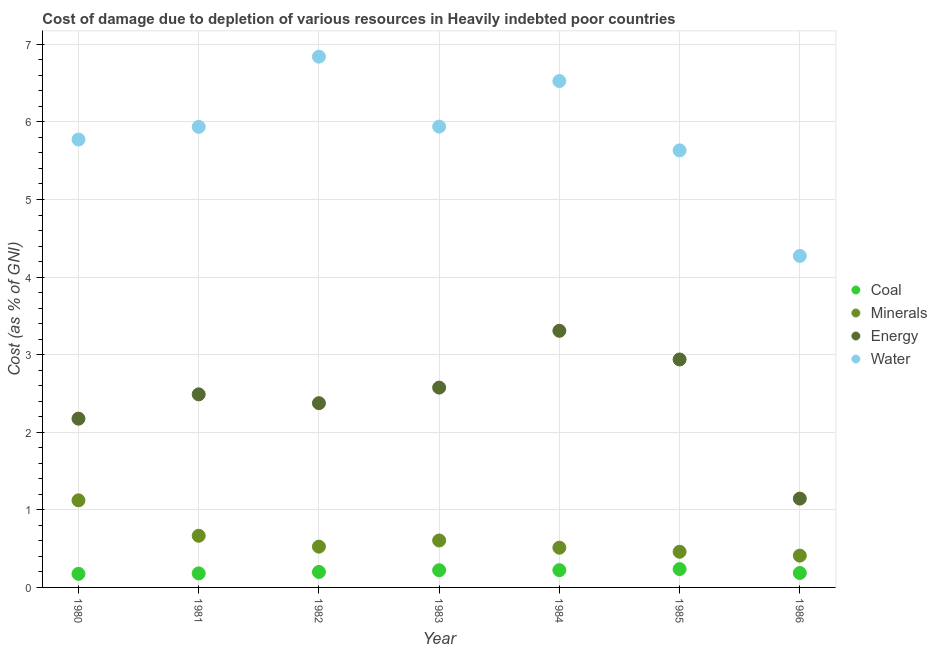How many different coloured dotlines are there?
Provide a succinct answer. 4. Is the number of dotlines equal to the number of legend labels?
Make the answer very short. Yes. What is the cost of damage due to depletion of coal in 1981?
Offer a very short reply. 0.18. Across all years, what is the maximum cost of damage due to depletion of water?
Your answer should be compact. 6.84. Across all years, what is the minimum cost of damage due to depletion of energy?
Offer a very short reply. 1.14. In which year was the cost of damage due to depletion of water maximum?
Ensure brevity in your answer.  1982. What is the total cost of damage due to depletion of energy in the graph?
Give a very brief answer. 17. What is the difference between the cost of damage due to depletion of water in 1980 and that in 1985?
Offer a terse response. 0.14. What is the difference between the cost of damage due to depletion of coal in 1981 and the cost of damage due to depletion of minerals in 1986?
Offer a very short reply. -0.23. What is the average cost of damage due to depletion of minerals per year?
Provide a short and direct response. 0.61. In the year 1981, what is the difference between the cost of damage due to depletion of water and cost of damage due to depletion of minerals?
Your answer should be very brief. 5.27. In how many years, is the cost of damage due to depletion of energy greater than 1.8 %?
Give a very brief answer. 6. What is the ratio of the cost of damage due to depletion of water in 1980 to that in 1986?
Keep it short and to the point. 1.35. What is the difference between the highest and the second highest cost of damage due to depletion of coal?
Offer a terse response. 0.01. What is the difference between the highest and the lowest cost of damage due to depletion of minerals?
Make the answer very short. 0.71. Is it the case that in every year, the sum of the cost of damage due to depletion of coal and cost of damage due to depletion of minerals is greater than the cost of damage due to depletion of energy?
Your response must be concise. No. Does the cost of damage due to depletion of energy monotonically increase over the years?
Your answer should be very brief. No. Is the cost of damage due to depletion of minerals strictly greater than the cost of damage due to depletion of water over the years?
Your answer should be compact. No. Is the cost of damage due to depletion of water strictly less than the cost of damage due to depletion of coal over the years?
Keep it short and to the point. No. How many dotlines are there?
Provide a short and direct response. 4. How many years are there in the graph?
Provide a succinct answer. 7. Does the graph contain grids?
Offer a terse response. Yes. Where does the legend appear in the graph?
Provide a short and direct response. Center right. How many legend labels are there?
Provide a succinct answer. 4. What is the title of the graph?
Give a very brief answer. Cost of damage due to depletion of various resources in Heavily indebted poor countries . Does "Secondary vocational education" appear as one of the legend labels in the graph?
Offer a terse response. No. What is the label or title of the X-axis?
Your answer should be very brief. Year. What is the label or title of the Y-axis?
Provide a succinct answer. Cost (as % of GNI). What is the Cost (as % of GNI) in Coal in 1980?
Offer a very short reply. 0.18. What is the Cost (as % of GNI) in Minerals in 1980?
Offer a terse response. 1.12. What is the Cost (as % of GNI) of Energy in 1980?
Offer a terse response. 2.18. What is the Cost (as % of GNI) of Water in 1980?
Make the answer very short. 5.77. What is the Cost (as % of GNI) of Coal in 1981?
Provide a short and direct response. 0.18. What is the Cost (as % of GNI) of Minerals in 1981?
Ensure brevity in your answer.  0.67. What is the Cost (as % of GNI) in Energy in 1981?
Provide a short and direct response. 2.49. What is the Cost (as % of GNI) in Water in 1981?
Offer a terse response. 5.94. What is the Cost (as % of GNI) in Coal in 1982?
Ensure brevity in your answer.  0.2. What is the Cost (as % of GNI) in Minerals in 1982?
Your answer should be compact. 0.53. What is the Cost (as % of GNI) in Energy in 1982?
Your answer should be compact. 2.37. What is the Cost (as % of GNI) in Water in 1982?
Provide a succinct answer. 6.84. What is the Cost (as % of GNI) of Coal in 1983?
Provide a short and direct response. 0.22. What is the Cost (as % of GNI) of Minerals in 1983?
Your response must be concise. 0.61. What is the Cost (as % of GNI) in Energy in 1983?
Your response must be concise. 2.58. What is the Cost (as % of GNI) in Water in 1983?
Give a very brief answer. 5.94. What is the Cost (as % of GNI) in Coal in 1984?
Your answer should be compact. 0.22. What is the Cost (as % of GNI) of Minerals in 1984?
Your answer should be compact. 0.51. What is the Cost (as % of GNI) in Energy in 1984?
Ensure brevity in your answer.  3.31. What is the Cost (as % of GNI) in Water in 1984?
Ensure brevity in your answer.  6.53. What is the Cost (as % of GNI) of Coal in 1985?
Offer a very short reply. 0.24. What is the Cost (as % of GNI) in Minerals in 1985?
Your answer should be compact. 0.46. What is the Cost (as % of GNI) of Energy in 1985?
Your answer should be very brief. 2.94. What is the Cost (as % of GNI) in Water in 1985?
Give a very brief answer. 5.63. What is the Cost (as % of GNI) in Coal in 1986?
Ensure brevity in your answer.  0.19. What is the Cost (as % of GNI) of Minerals in 1986?
Make the answer very short. 0.41. What is the Cost (as % of GNI) of Energy in 1986?
Give a very brief answer. 1.14. What is the Cost (as % of GNI) of Water in 1986?
Keep it short and to the point. 4.27. Across all years, what is the maximum Cost (as % of GNI) of Coal?
Ensure brevity in your answer.  0.24. Across all years, what is the maximum Cost (as % of GNI) in Minerals?
Provide a succinct answer. 1.12. Across all years, what is the maximum Cost (as % of GNI) of Energy?
Provide a succinct answer. 3.31. Across all years, what is the maximum Cost (as % of GNI) in Water?
Your answer should be compact. 6.84. Across all years, what is the minimum Cost (as % of GNI) in Coal?
Give a very brief answer. 0.18. Across all years, what is the minimum Cost (as % of GNI) of Minerals?
Make the answer very short. 0.41. Across all years, what is the minimum Cost (as % of GNI) in Energy?
Provide a short and direct response. 1.14. Across all years, what is the minimum Cost (as % of GNI) of Water?
Provide a short and direct response. 4.27. What is the total Cost (as % of GNI) in Coal in the graph?
Offer a terse response. 1.42. What is the total Cost (as % of GNI) of Minerals in the graph?
Your answer should be very brief. 4.3. What is the total Cost (as % of GNI) of Energy in the graph?
Provide a short and direct response. 17. What is the total Cost (as % of GNI) of Water in the graph?
Provide a succinct answer. 40.92. What is the difference between the Cost (as % of GNI) in Coal in 1980 and that in 1981?
Offer a terse response. -0.01. What is the difference between the Cost (as % of GNI) in Minerals in 1980 and that in 1981?
Your response must be concise. 0.46. What is the difference between the Cost (as % of GNI) in Energy in 1980 and that in 1981?
Offer a very short reply. -0.31. What is the difference between the Cost (as % of GNI) in Water in 1980 and that in 1981?
Your answer should be compact. -0.16. What is the difference between the Cost (as % of GNI) of Coal in 1980 and that in 1982?
Your response must be concise. -0.02. What is the difference between the Cost (as % of GNI) of Minerals in 1980 and that in 1982?
Keep it short and to the point. 0.6. What is the difference between the Cost (as % of GNI) of Energy in 1980 and that in 1982?
Provide a succinct answer. -0.2. What is the difference between the Cost (as % of GNI) in Water in 1980 and that in 1982?
Make the answer very short. -1.07. What is the difference between the Cost (as % of GNI) in Coal in 1980 and that in 1983?
Ensure brevity in your answer.  -0.05. What is the difference between the Cost (as % of GNI) in Minerals in 1980 and that in 1983?
Your answer should be very brief. 0.52. What is the difference between the Cost (as % of GNI) of Energy in 1980 and that in 1983?
Your answer should be very brief. -0.4. What is the difference between the Cost (as % of GNI) in Coal in 1980 and that in 1984?
Make the answer very short. -0.05. What is the difference between the Cost (as % of GNI) of Minerals in 1980 and that in 1984?
Keep it short and to the point. 0.61. What is the difference between the Cost (as % of GNI) of Energy in 1980 and that in 1984?
Make the answer very short. -1.13. What is the difference between the Cost (as % of GNI) of Water in 1980 and that in 1984?
Provide a succinct answer. -0.75. What is the difference between the Cost (as % of GNI) of Coal in 1980 and that in 1985?
Make the answer very short. -0.06. What is the difference between the Cost (as % of GNI) in Minerals in 1980 and that in 1985?
Keep it short and to the point. 0.66. What is the difference between the Cost (as % of GNI) in Energy in 1980 and that in 1985?
Provide a short and direct response. -0.76. What is the difference between the Cost (as % of GNI) of Water in 1980 and that in 1985?
Provide a short and direct response. 0.14. What is the difference between the Cost (as % of GNI) in Coal in 1980 and that in 1986?
Your answer should be very brief. -0.01. What is the difference between the Cost (as % of GNI) of Minerals in 1980 and that in 1986?
Provide a succinct answer. 0.71. What is the difference between the Cost (as % of GNI) in Energy in 1980 and that in 1986?
Keep it short and to the point. 1.03. What is the difference between the Cost (as % of GNI) of Water in 1980 and that in 1986?
Keep it short and to the point. 1.5. What is the difference between the Cost (as % of GNI) of Coal in 1981 and that in 1982?
Keep it short and to the point. -0.02. What is the difference between the Cost (as % of GNI) in Minerals in 1981 and that in 1982?
Provide a succinct answer. 0.14. What is the difference between the Cost (as % of GNI) of Energy in 1981 and that in 1982?
Keep it short and to the point. 0.11. What is the difference between the Cost (as % of GNI) of Water in 1981 and that in 1982?
Your answer should be very brief. -0.9. What is the difference between the Cost (as % of GNI) in Coal in 1981 and that in 1983?
Ensure brevity in your answer.  -0.04. What is the difference between the Cost (as % of GNI) in Minerals in 1981 and that in 1983?
Provide a succinct answer. 0.06. What is the difference between the Cost (as % of GNI) in Energy in 1981 and that in 1983?
Give a very brief answer. -0.09. What is the difference between the Cost (as % of GNI) of Water in 1981 and that in 1983?
Your response must be concise. -0. What is the difference between the Cost (as % of GNI) of Coal in 1981 and that in 1984?
Your answer should be very brief. -0.04. What is the difference between the Cost (as % of GNI) of Minerals in 1981 and that in 1984?
Ensure brevity in your answer.  0.15. What is the difference between the Cost (as % of GNI) of Energy in 1981 and that in 1984?
Ensure brevity in your answer.  -0.82. What is the difference between the Cost (as % of GNI) of Water in 1981 and that in 1984?
Keep it short and to the point. -0.59. What is the difference between the Cost (as % of GNI) of Coal in 1981 and that in 1985?
Make the answer very short. -0.06. What is the difference between the Cost (as % of GNI) in Minerals in 1981 and that in 1985?
Offer a terse response. 0.21. What is the difference between the Cost (as % of GNI) of Energy in 1981 and that in 1985?
Give a very brief answer. -0.45. What is the difference between the Cost (as % of GNI) in Water in 1981 and that in 1985?
Your answer should be very brief. 0.3. What is the difference between the Cost (as % of GNI) in Coal in 1981 and that in 1986?
Your response must be concise. -0.01. What is the difference between the Cost (as % of GNI) of Minerals in 1981 and that in 1986?
Your response must be concise. 0.26. What is the difference between the Cost (as % of GNI) in Energy in 1981 and that in 1986?
Provide a succinct answer. 1.34. What is the difference between the Cost (as % of GNI) of Water in 1981 and that in 1986?
Offer a very short reply. 1.66. What is the difference between the Cost (as % of GNI) in Coal in 1982 and that in 1983?
Offer a very short reply. -0.02. What is the difference between the Cost (as % of GNI) in Minerals in 1982 and that in 1983?
Provide a succinct answer. -0.08. What is the difference between the Cost (as % of GNI) in Energy in 1982 and that in 1983?
Offer a very short reply. -0.2. What is the difference between the Cost (as % of GNI) in Water in 1982 and that in 1983?
Ensure brevity in your answer.  0.9. What is the difference between the Cost (as % of GNI) in Coal in 1982 and that in 1984?
Offer a terse response. -0.02. What is the difference between the Cost (as % of GNI) in Minerals in 1982 and that in 1984?
Provide a short and direct response. 0.01. What is the difference between the Cost (as % of GNI) in Energy in 1982 and that in 1984?
Offer a very short reply. -0.93. What is the difference between the Cost (as % of GNI) in Water in 1982 and that in 1984?
Offer a terse response. 0.31. What is the difference between the Cost (as % of GNI) of Coal in 1982 and that in 1985?
Your response must be concise. -0.04. What is the difference between the Cost (as % of GNI) of Minerals in 1982 and that in 1985?
Offer a terse response. 0.07. What is the difference between the Cost (as % of GNI) in Energy in 1982 and that in 1985?
Ensure brevity in your answer.  -0.56. What is the difference between the Cost (as % of GNI) in Water in 1982 and that in 1985?
Give a very brief answer. 1.21. What is the difference between the Cost (as % of GNI) in Coal in 1982 and that in 1986?
Your answer should be very brief. 0.01. What is the difference between the Cost (as % of GNI) of Minerals in 1982 and that in 1986?
Ensure brevity in your answer.  0.12. What is the difference between the Cost (as % of GNI) of Energy in 1982 and that in 1986?
Offer a terse response. 1.23. What is the difference between the Cost (as % of GNI) of Water in 1982 and that in 1986?
Your answer should be very brief. 2.57. What is the difference between the Cost (as % of GNI) of Coal in 1983 and that in 1984?
Your response must be concise. -0. What is the difference between the Cost (as % of GNI) in Minerals in 1983 and that in 1984?
Your response must be concise. 0.09. What is the difference between the Cost (as % of GNI) of Energy in 1983 and that in 1984?
Make the answer very short. -0.73. What is the difference between the Cost (as % of GNI) of Water in 1983 and that in 1984?
Ensure brevity in your answer.  -0.59. What is the difference between the Cost (as % of GNI) of Coal in 1983 and that in 1985?
Your answer should be very brief. -0.01. What is the difference between the Cost (as % of GNI) of Minerals in 1983 and that in 1985?
Your answer should be compact. 0.15. What is the difference between the Cost (as % of GNI) in Energy in 1983 and that in 1985?
Give a very brief answer. -0.36. What is the difference between the Cost (as % of GNI) of Water in 1983 and that in 1985?
Make the answer very short. 0.31. What is the difference between the Cost (as % of GNI) in Coal in 1983 and that in 1986?
Your answer should be compact. 0.04. What is the difference between the Cost (as % of GNI) of Minerals in 1983 and that in 1986?
Give a very brief answer. 0.2. What is the difference between the Cost (as % of GNI) of Energy in 1983 and that in 1986?
Give a very brief answer. 1.43. What is the difference between the Cost (as % of GNI) in Water in 1983 and that in 1986?
Ensure brevity in your answer.  1.67. What is the difference between the Cost (as % of GNI) in Coal in 1984 and that in 1985?
Keep it short and to the point. -0.01. What is the difference between the Cost (as % of GNI) in Minerals in 1984 and that in 1985?
Your answer should be very brief. 0.05. What is the difference between the Cost (as % of GNI) in Energy in 1984 and that in 1985?
Provide a succinct answer. 0.37. What is the difference between the Cost (as % of GNI) in Water in 1984 and that in 1985?
Provide a short and direct response. 0.89. What is the difference between the Cost (as % of GNI) in Coal in 1984 and that in 1986?
Make the answer very short. 0.04. What is the difference between the Cost (as % of GNI) of Minerals in 1984 and that in 1986?
Give a very brief answer. 0.1. What is the difference between the Cost (as % of GNI) in Energy in 1984 and that in 1986?
Provide a succinct answer. 2.16. What is the difference between the Cost (as % of GNI) in Water in 1984 and that in 1986?
Your response must be concise. 2.25. What is the difference between the Cost (as % of GNI) in Coal in 1985 and that in 1986?
Provide a succinct answer. 0.05. What is the difference between the Cost (as % of GNI) of Minerals in 1985 and that in 1986?
Keep it short and to the point. 0.05. What is the difference between the Cost (as % of GNI) in Energy in 1985 and that in 1986?
Offer a very short reply. 1.79. What is the difference between the Cost (as % of GNI) of Water in 1985 and that in 1986?
Offer a terse response. 1.36. What is the difference between the Cost (as % of GNI) in Coal in 1980 and the Cost (as % of GNI) in Minerals in 1981?
Your response must be concise. -0.49. What is the difference between the Cost (as % of GNI) in Coal in 1980 and the Cost (as % of GNI) in Energy in 1981?
Your answer should be very brief. -2.31. What is the difference between the Cost (as % of GNI) of Coal in 1980 and the Cost (as % of GNI) of Water in 1981?
Your answer should be very brief. -5.76. What is the difference between the Cost (as % of GNI) of Minerals in 1980 and the Cost (as % of GNI) of Energy in 1981?
Your answer should be compact. -1.37. What is the difference between the Cost (as % of GNI) of Minerals in 1980 and the Cost (as % of GNI) of Water in 1981?
Ensure brevity in your answer.  -4.81. What is the difference between the Cost (as % of GNI) in Energy in 1980 and the Cost (as % of GNI) in Water in 1981?
Your answer should be compact. -3.76. What is the difference between the Cost (as % of GNI) in Coal in 1980 and the Cost (as % of GNI) in Minerals in 1982?
Offer a very short reply. -0.35. What is the difference between the Cost (as % of GNI) in Coal in 1980 and the Cost (as % of GNI) in Energy in 1982?
Ensure brevity in your answer.  -2.2. What is the difference between the Cost (as % of GNI) in Coal in 1980 and the Cost (as % of GNI) in Water in 1982?
Your answer should be very brief. -6.67. What is the difference between the Cost (as % of GNI) of Minerals in 1980 and the Cost (as % of GNI) of Energy in 1982?
Give a very brief answer. -1.25. What is the difference between the Cost (as % of GNI) of Minerals in 1980 and the Cost (as % of GNI) of Water in 1982?
Offer a very short reply. -5.72. What is the difference between the Cost (as % of GNI) in Energy in 1980 and the Cost (as % of GNI) in Water in 1982?
Make the answer very short. -4.67. What is the difference between the Cost (as % of GNI) in Coal in 1980 and the Cost (as % of GNI) in Minerals in 1983?
Your answer should be compact. -0.43. What is the difference between the Cost (as % of GNI) in Coal in 1980 and the Cost (as % of GNI) in Energy in 1983?
Offer a terse response. -2.4. What is the difference between the Cost (as % of GNI) of Coal in 1980 and the Cost (as % of GNI) of Water in 1983?
Your response must be concise. -5.76. What is the difference between the Cost (as % of GNI) in Minerals in 1980 and the Cost (as % of GNI) in Energy in 1983?
Your response must be concise. -1.45. What is the difference between the Cost (as % of GNI) in Minerals in 1980 and the Cost (as % of GNI) in Water in 1983?
Offer a very short reply. -4.82. What is the difference between the Cost (as % of GNI) of Energy in 1980 and the Cost (as % of GNI) of Water in 1983?
Keep it short and to the point. -3.76. What is the difference between the Cost (as % of GNI) of Coal in 1980 and the Cost (as % of GNI) of Minerals in 1984?
Offer a very short reply. -0.34. What is the difference between the Cost (as % of GNI) of Coal in 1980 and the Cost (as % of GNI) of Energy in 1984?
Your answer should be compact. -3.13. What is the difference between the Cost (as % of GNI) in Coal in 1980 and the Cost (as % of GNI) in Water in 1984?
Your response must be concise. -6.35. What is the difference between the Cost (as % of GNI) of Minerals in 1980 and the Cost (as % of GNI) of Energy in 1984?
Keep it short and to the point. -2.19. What is the difference between the Cost (as % of GNI) of Minerals in 1980 and the Cost (as % of GNI) of Water in 1984?
Your answer should be compact. -5.4. What is the difference between the Cost (as % of GNI) of Energy in 1980 and the Cost (as % of GNI) of Water in 1984?
Your answer should be very brief. -4.35. What is the difference between the Cost (as % of GNI) in Coal in 1980 and the Cost (as % of GNI) in Minerals in 1985?
Your answer should be compact. -0.28. What is the difference between the Cost (as % of GNI) of Coal in 1980 and the Cost (as % of GNI) of Energy in 1985?
Provide a short and direct response. -2.76. What is the difference between the Cost (as % of GNI) of Coal in 1980 and the Cost (as % of GNI) of Water in 1985?
Your answer should be compact. -5.46. What is the difference between the Cost (as % of GNI) of Minerals in 1980 and the Cost (as % of GNI) of Energy in 1985?
Your answer should be compact. -1.82. What is the difference between the Cost (as % of GNI) of Minerals in 1980 and the Cost (as % of GNI) of Water in 1985?
Make the answer very short. -4.51. What is the difference between the Cost (as % of GNI) of Energy in 1980 and the Cost (as % of GNI) of Water in 1985?
Provide a short and direct response. -3.46. What is the difference between the Cost (as % of GNI) in Coal in 1980 and the Cost (as % of GNI) in Minerals in 1986?
Make the answer very short. -0.23. What is the difference between the Cost (as % of GNI) in Coal in 1980 and the Cost (as % of GNI) in Energy in 1986?
Provide a succinct answer. -0.97. What is the difference between the Cost (as % of GNI) of Coal in 1980 and the Cost (as % of GNI) of Water in 1986?
Offer a very short reply. -4.1. What is the difference between the Cost (as % of GNI) in Minerals in 1980 and the Cost (as % of GNI) in Energy in 1986?
Provide a short and direct response. -0.02. What is the difference between the Cost (as % of GNI) of Minerals in 1980 and the Cost (as % of GNI) of Water in 1986?
Provide a succinct answer. -3.15. What is the difference between the Cost (as % of GNI) in Energy in 1980 and the Cost (as % of GNI) in Water in 1986?
Your answer should be very brief. -2.1. What is the difference between the Cost (as % of GNI) in Coal in 1981 and the Cost (as % of GNI) in Minerals in 1982?
Your answer should be very brief. -0.34. What is the difference between the Cost (as % of GNI) of Coal in 1981 and the Cost (as % of GNI) of Energy in 1982?
Provide a short and direct response. -2.19. What is the difference between the Cost (as % of GNI) of Coal in 1981 and the Cost (as % of GNI) of Water in 1982?
Your answer should be compact. -6.66. What is the difference between the Cost (as % of GNI) of Minerals in 1981 and the Cost (as % of GNI) of Energy in 1982?
Offer a very short reply. -1.71. What is the difference between the Cost (as % of GNI) in Minerals in 1981 and the Cost (as % of GNI) in Water in 1982?
Make the answer very short. -6.17. What is the difference between the Cost (as % of GNI) of Energy in 1981 and the Cost (as % of GNI) of Water in 1982?
Ensure brevity in your answer.  -4.35. What is the difference between the Cost (as % of GNI) of Coal in 1981 and the Cost (as % of GNI) of Minerals in 1983?
Provide a short and direct response. -0.42. What is the difference between the Cost (as % of GNI) in Coal in 1981 and the Cost (as % of GNI) in Energy in 1983?
Keep it short and to the point. -2.39. What is the difference between the Cost (as % of GNI) in Coal in 1981 and the Cost (as % of GNI) in Water in 1983?
Your answer should be compact. -5.76. What is the difference between the Cost (as % of GNI) of Minerals in 1981 and the Cost (as % of GNI) of Energy in 1983?
Offer a terse response. -1.91. What is the difference between the Cost (as % of GNI) in Minerals in 1981 and the Cost (as % of GNI) in Water in 1983?
Ensure brevity in your answer.  -5.27. What is the difference between the Cost (as % of GNI) of Energy in 1981 and the Cost (as % of GNI) of Water in 1983?
Provide a short and direct response. -3.45. What is the difference between the Cost (as % of GNI) of Coal in 1981 and the Cost (as % of GNI) of Minerals in 1984?
Make the answer very short. -0.33. What is the difference between the Cost (as % of GNI) of Coal in 1981 and the Cost (as % of GNI) of Energy in 1984?
Offer a very short reply. -3.13. What is the difference between the Cost (as % of GNI) of Coal in 1981 and the Cost (as % of GNI) of Water in 1984?
Your answer should be compact. -6.35. What is the difference between the Cost (as % of GNI) in Minerals in 1981 and the Cost (as % of GNI) in Energy in 1984?
Keep it short and to the point. -2.64. What is the difference between the Cost (as % of GNI) of Minerals in 1981 and the Cost (as % of GNI) of Water in 1984?
Your response must be concise. -5.86. What is the difference between the Cost (as % of GNI) of Energy in 1981 and the Cost (as % of GNI) of Water in 1984?
Your answer should be compact. -4.04. What is the difference between the Cost (as % of GNI) in Coal in 1981 and the Cost (as % of GNI) in Minerals in 1985?
Your answer should be very brief. -0.28. What is the difference between the Cost (as % of GNI) in Coal in 1981 and the Cost (as % of GNI) in Energy in 1985?
Your response must be concise. -2.76. What is the difference between the Cost (as % of GNI) of Coal in 1981 and the Cost (as % of GNI) of Water in 1985?
Provide a succinct answer. -5.45. What is the difference between the Cost (as % of GNI) in Minerals in 1981 and the Cost (as % of GNI) in Energy in 1985?
Make the answer very short. -2.27. What is the difference between the Cost (as % of GNI) of Minerals in 1981 and the Cost (as % of GNI) of Water in 1985?
Your answer should be very brief. -4.97. What is the difference between the Cost (as % of GNI) in Energy in 1981 and the Cost (as % of GNI) in Water in 1985?
Ensure brevity in your answer.  -3.14. What is the difference between the Cost (as % of GNI) in Coal in 1981 and the Cost (as % of GNI) in Minerals in 1986?
Give a very brief answer. -0.23. What is the difference between the Cost (as % of GNI) of Coal in 1981 and the Cost (as % of GNI) of Energy in 1986?
Your response must be concise. -0.96. What is the difference between the Cost (as % of GNI) of Coal in 1981 and the Cost (as % of GNI) of Water in 1986?
Offer a very short reply. -4.09. What is the difference between the Cost (as % of GNI) of Minerals in 1981 and the Cost (as % of GNI) of Energy in 1986?
Offer a very short reply. -0.48. What is the difference between the Cost (as % of GNI) of Minerals in 1981 and the Cost (as % of GNI) of Water in 1986?
Your response must be concise. -3.61. What is the difference between the Cost (as % of GNI) of Energy in 1981 and the Cost (as % of GNI) of Water in 1986?
Ensure brevity in your answer.  -1.78. What is the difference between the Cost (as % of GNI) of Coal in 1982 and the Cost (as % of GNI) of Minerals in 1983?
Your answer should be very brief. -0.41. What is the difference between the Cost (as % of GNI) of Coal in 1982 and the Cost (as % of GNI) of Energy in 1983?
Provide a short and direct response. -2.38. What is the difference between the Cost (as % of GNI) of Coal in 1982 and the Cost (as % of GNI) of Water in 1983?
Ensure brevity in your answer.  -5.74. What is the difference between the Cost (as % of GNI) of Minerals in 1982 and the Cost (as % of GNI) of Energy in 1983?
Your answer should be very brief. -2.05. What is the difference between the Cost (as % of GNI) of Minerals in 1982 and the Cost (as % of GNI) of Water in 1983?
Offer a terse response. -5.41. What is the difference between the Cost (as % of GNI) of Energy in 1982 and the Cost (as % of GNI) of Water in 1983?
Offer a terse response. -3.56. What is the difference between the Cost (as % of GNI) of Coal in 1982 and the Cost (as % of GNI) of Minerals in 1984?
Offer a terse response. -0.31. What is the difference between the Cost (as % of GNI) of Coal in 1982 and the Cost (as % of GNI) of Energy in 1984?
Keep it short and to the point. -3.11. What is the difference between the Cost (as % of GNI) of Coal in 1982 and the Cost (as % of GNI) of Water in 1984?
Offer a terse response. -6.33. What is the difference between the Cost (as % of GNI) of Minerals in 1982 and the Cost (as % of GNI) of Energy in 1984?
Your response must be concise. -2.78. What is the difference between the Cost (as % of GNI) of Minerals in 1982 and the Cost (as % of GNI) of Water in 1984?
Make the answer very short. -6. What is the difference between the Cost (as % of GNI) of Energy in 1982 and the Cost (as % of GNI) of Water in 1984?
Your answer should be compact. -4.15. What is the difference between the Cost (as % of GNI) in Coal in 1982 and the Cost (as % of GNI) in Minerals in 1985?
Offer a terse response. -0.26. What is the difference between the Cost (as % of GNI) in Coal in 1982 and the Cost (as % of GNI) in Energy in 1985?
Keep it short and to the point. -2.74. What is the difference between the Cost (as % of GNI) of Coal in 1982 and the Cost (as % of GNI) of Water in 1985?
Your answer should be very brief. -5.43. What is the difference between the Cost (as % of GNI) in Minerals in 1982 and the Cost (as % of GNI) in Energy in 1985?
Make the answer very short. -2.41. What is the difference between the Cost (as % of GNI) in Minerals in 1982 and the Cost (as % of GNI) in Water in 1985?
Give a very brief answer. -5.11. What is the difference between the Cost (as % of GNI) of Energy in 1982 and the Cost (as % of GNI) of Water in 1985?
Give a very brief answer. -3.26. What is the difference between the Cost (as % of GNI) of Coal in 1982 and the Cost (as % of GNI) of Minerals in 1986?
Give a very brief answer. -0.21. What is the difference between the Cost (as % of GNI) of Coal in 1982 and the Cost (as % of GNI) of Energy in 1986?
Keep it short and to the point. -0.95. What is the difference between the Cost (as % of GNI) in Coal in 1982 and the Cost (as % of GNI) in Water in 1986?
Your answer should be compact. -4.07. What is the difference between the Cost (as % of GNI) of Minerals in 1982 and the Cost (as % of GNI) of Energy in 1986?
Your answer should be very brief. -0.62. What is the difference between the Cost (as % of GNI) in Minerals in 1982 and the Cost (as % of GNI) in Water in 1986?
Keep it short and to the point. -3.75. What is the difference between the Cost (as % of GNI) of Energy in 1982 and the Cost (as % of GNI) of Water in 1986?
Offer a very short reply. -1.9. What is the difference between the Cost (as % of GNI) in Coal in 1983 and the Cost (as % of GNI) in Minerals in 1984?
Your response must be concise. -0.29. What is the difference between the Cost (as % of GNI) in Coal in 1983 and the Cost (as % of GNI) in Energy in 1984?
Offer a very short reply. -3.09. What is the difference between the Cost (as % of GNI) of Coal in 1983 and the Cost (as % of GNI) of Water in 1984?
Make the answer very short. -6.3. What is the difference between the Cost (as % of GNI) of Minerals in 1983 and the Cost (as % of GNI) of Energy in 1984?
Provide a succinct answer. -2.7. What is the difference between the Cost (as % of GNI) of Minerals in 1983 and the Cost (as % of GNI) of Water in 1984?
Make the answer very short. -5.92. What is the difference between the Cost (as % of GNI) of Energy in 1983 and the Cost (as % of GNI) of Water in 1984?
Your response must be concise. -3.95. What is the difference between the Cost (as % of GNI) in Coal in 1983 and the Cost (as % of GNI) in Minerals in 1985?
Make the answer very short. -0.24. What is the difference between the Cost (as % of GNI) in Coal in 1983 and the Cost (as % of GNI) in Energy in 1985?
Make the answer very short. -2.72. What is the difference between the Cost (as % of GNI) in Coal in 1983 and the Cost (as % of GNI) in Water in 1985?
Your response must be concise. -5.41. What is the difference between the Cost (as % of GNI) in Minerals in 1983 and the Cost (as % of GNI) in Energy in 1985?
Ensure brevity in your answer.  -2.33. What is the difference between the Cost (as % of GNI) of Minerals in 1983 and the Cost (as % of GNI) of Water in 1985?
Provide a short and direct response. -5.03. What is the difference between the Cost (as % of GNI) of Energy in 1983 and the Cost (as % of GNI) of Water in 1985?
Provide a succinct answer. -3.06. What is the difference between the Cost (as % of GNI) of Coal in 1983 and the Cost (as % of GNI) of Minerals in 1986?
Keep it short and to the point. -0.19. What is the difference between the Cost (as % of GNI) of Coal in 1983 and the Cost (as % of GNI) of Energy in 1986?
Keep it short and to the point. -0.92. What is the difference between the Cost (as % of GNI) of Coal in 1983 and the Cost (as % of GNI) of Water in 1986?
Make the answer very short. -4.05. What is the difference between the Cost (as % of GNI) in Minerals in 1983 and the Cost (as % of GNI) in Energy in 1986?
Provide a succinct answer. -0.54. What is the difference between the Cost (as % of GNI) of Minerals in 1983 and the Cost (as % of GNI) of Water in 1986?
Provide a succinct answer. -3.67. What is the difference between the Cost (as % of GNI) in Energy in 1983 and the Cost (as % of GNI) in Water in 1986?
Provide a succinct answer. -1.7. What is the difference between the Cost (as % of GNI) in Coal in 1984 and the Cost (as % of GNI) in Minerals in 1985?
Your answer should be compact. -0.24. What is the difference between the Cost (as % of GNI) of Coal in 1984 and the Cost (as % of GNI) of Energy in 1985?
Keep it short and to the point. -2.72. What is the difference between the Cost (as % of GNI) in Coal in 1984 and the Cost (as % of GNI) in Water in 1985?
Your answer should be compact. -5.41. What is the difference between the Cost (as % of GNI) in Minerals in 1984 and the Cost (as % of GNI) in Energy in 1985?
Provide a short and direct response. -2.43. What is the difference between the Cost (as % of GNI) of Minerals in 1984 and the Cost (as % of GNI) of Water in 1985?
Offer a terse response. -5.12. What is the difference between the Cost (as % of GNI) of Energy in 1984 and the Cost (as % of GNI) of Water in 1985?
Provide a succinct answer. -2.33. What is the difference between the Cost (as % of GNI) of Coal in 1984 and the Cost (as % of GNI) of Minerals in 1986?
Provide a succinct answer. -0.19. What is the difference between the Cost (as % of GNI) in Coal in 1984 and the Cost (as % of GNI) in Energy in 1986?
Your answer should be compact. -0.92. What is the difference between the Cost (as % of GNI) in Coal in 1984 and the Cost (as % of GNI) in Water in 1986?
Keep it short and to the point. -4.05. What is the difference between the Cost (as % of GNI) of Minerals in 1984 and the Cost (as % of GNI) of Energy in 1986?
Ensure brevity in your answer.  -0.63. What is the difference between the Cost (as % of GNI) of Minerals in 1984 and the Cost (as % of GNI) of Water in 1986?
Your response must be concise. -3.76. What is the difference between the Cost (as % of GNI) in Energy in 1984 and the Cost (as % of GNI) in Water in 1986?
Provide a succinct answer. -0.96. What is the difference between the Cost (as % of GNI) in Coal in 1985 and the Cost (as % of GNI) in Minerals in 1986?
Give a very brief answer. -0.17. What is the difference between the Cost (as % of GNI) of Coal in 1985 and the Cost (as % of GNI) of Energy in 1986?
Give a very brief answer. -0.91. What is the difference between the Cost (as % of GNI) in Coal in 1985 and the Cost (as % of GNI) in Water in 1986?
Provide a succinct answer. -4.04. What is the difference between the Cost (as % of GNI) in Minerals in 1985 and the Cost (as % of GNI) in Energy in 1986?
Provide a short and direct response. -0.69. What is the difference between the Cost (as % of GNI) in Minerals in 1985 and the Cost (as % of GNI) in Water in 1986?
Give a very brief answer. -3.81. What is the difference between the Cost (as % of GNI) in Energy in 1985 and the Cost (as % of GNI) in Water in 1986?
Make the answer very short. -1.33. What is the average Cost (as % of GNI) of Coal per year?
Ensure brevity in your answer.  0.2. What is the average Cost (as % of GNI) of Minerals per year?
Provide a succinct answer. 0.61. What is the average Cost (as % of GNI) of Energy per year?
Ensure brevity in your answer.  2.43. What is the average Cost (as % of GNI) of Water per year?
Offer a terse response. 5.85. In the year 1980, what is the difference between the Cost (as % of GNI) of Coal and Cost (as % of GNI) of Minerals?
Your response must be concise. -0.95. In the year 1980, what is the difference between the Cost (as % of GNI) in Coal and Cost (as % of GNI) in Water?
Your answer should be compact. -5.6. In the year 1980, what is the difference between the Cost (as % of GNI) of Minerals and Cost (as % of GNI) of Energy?
Ensure brevity in your answer.  -1.05. In the year 1980, what is the difference between the Cost (as % of GNI) of Minerals and Cost (as % of GNI) of Water?
Ensure brevity in your answer.  -4.65. In the year 1980, what is the difference between the Cost (as % of GNI) of Energy and Cost (as % of GNI) of Water?
Keep it short and to the point. -3.6. In the year 1981, what is the difference between the Cost (as % of GNI) in Coal and Cost (as % of GNI) in Minerals?
Your answer should be very brief. -0.48. In the year 1981, what is the difference between the Cost (as % of GNI) in Coal and Cost (as % of GNI) in Energy?
Provide a succinct answer. -2.31. In the year 1981, what is the difference between the Cost (as % of GNI) of Coal and Cost (as % of GNI) of Water?
Your response must be concise. -5.75. In the year 1981, what is the difference between the Cost (as % of GNI) of Minerals and Cost (as % of GNI) of Energy?
Provide a short and direct response. -1.82. In the year 1981, what is the difference between the Cost (as % of GNI) of Minerals and Cost (as % of GNI) of Water?
Offer a terse response. -5.27. In the year 1981, what is the difference between the Cost (as % of GNI) of Energy and Cost (as % of GNI) of Water?
Ensure brevity in your answer.  -3.45. In the year 1982, what is the difference between the Cost (as % of GNI) of Coal and Cost (as % of GNI) of Minerals?
Offer a terse response. -0.33. In the year 1982, what is the difference between the Cost (as % of GNI) of Coal and Cost (as % of GNI) of Energy?
Your answer should be very brief. -2.18. In the year 1982, what is the difference between the Cost (as % of GNI) of Coal and Cost (as % of GNI) of Water?
Your answer should be compact. -6.64. In the year 1982, what is the difference between the Cost (as % of GNI) of Minerals and Cost (as % of GNI) of Energy?
Your answer should be compact. -1.85. In the year 1982, what is the difference between the Cost (as % of GNI) in Minerals and Cost (as % of GNI) in Water?
Your answer should be very brief. -6.32. In the year 1982, what is the difference between the Cost (as % of GNI) of Energy and Cost (as % of GNI) of Water?
Make the answer very short. -4.47. In the year 1983, what is the difference between the Cost (as % of GNI) of Coal and Cost (as % of GNI) of Minerals?
Make the answer very short. -0.38. In the year 1983, what is the difference between the Cost (as % of GNI) in Coal and Cost (as % of GNI) in Energy?
Your response must be concise. -2.35. In the year 1983, what is the difference between the Cost (as % of GNI) in Coal and Cost (as % of GNI) in Water?
Offer a very short reply. -5.72. In the year 1983, what is the difference between the Cost (as % of GNI) of Minerals and Cost (as % of GNI) of Energy?
Your answer should be very brief. -1.97. In the year 1983, what is the difference between the Cost (as % of GNI) in Minerals and Cost (as % of GNI) in Water?
Make the answer very short. -5.33. In the year 1983, what is the difference between the Cost (as % of GNI) in Energy and Cost (as % of GNI) in Water?
Your answer should be compact. -3.36. In the year 1984, what is the difference between the Cost (as % of GNI) of Coal and Cost (as % of GNI) of Minerals?
Offer a terse response. -0.29. In the year 1984, what is the difference between the Cost (as % of GNI) in Coal and Cost (as % of GNI) in Energy?
Your response must be concise. -3.08. In the year 1984, what is the difference between the Cost (as % of GNI) of Coal and Cost (as % of GNI) of Water?
Give a very brief answer. -6.3. In the year 1984, what is the difference between the Cost (as % of GNI) of Minerals and Cost (as % of GNI) of Energy?
Offer a terse response. -2.8. In the year 1984, what is the difference between the Cost (as % of GNI) in Minerals and Cost (as % of GNI) in Water?
Offer a very short reply. -6.01. In the year 1984, what is the difference between the Cost (as % of GNI) of Energy and Cost (as % of GNI) of Water?
Provide a succinct answer. -3.22. In the year 1985, what is the difference between the Cost (as % of GNI) of Coal and Cost (as % of GNI) of Minerals?
Offer a terse response. -0.22. In the year 1985, what is the difference between the Cost (as % of GNI) of Coal and Cost (as % of GNI) of Energy?
Keep it short and to the point. -2.7. In the year 1985, what is the difference between the Cost (as % of GNI) in Coal and Cost (as % of GNI) in Water?
Your answer should be compact. -5.4. In the year 1985, what is the difference between the Cost (as % of GNI) in Minerals and Cost (as % of GNI) in Energy?
Your answer should be compact. -2.48. In the year 1985, what is the difference between the Cost (as % of GNI) in Minerals and Cost (as % of GNI) in Water?
Keep it short and to the point. -5.17. In the year 1985, what is the difference between the Cost (as % of GNI) in Energy and Cost (as % of GNI) in Water?
Provide a succinct answer. -2.69. In the year 1986, what is the difference between the Cost (as % of GNI) in Coal and Cost (as % of GNI) in Minerals?
Give a very brief answer. -0.22. In the year 1986, what is the difference between the Cost (as % of GNI) in Coal and Cost (as % of GNI) in Energy?
Make the answer very short. -0.96. In the year 1986, what is the difference between the Cost (as % of GNI) of Coal and Cost (as % of GNI) of Water?
Your answer should be compact. -4.09. In the year 1986, what is the difference between the Cost (as % of GNI) of Minerals and Cost (as % of GNI) of Energy?
Give a very brief answer. -0.73. In the year 1986, what is the difference between the Cost (as % of GNI) of Minerals and Cost (as % of GNI) of Water?
Your response must be concise. -3.86. In the year 1986, what is the difference between the Cost (as % of GNI) in Energy and Cost (as % of GNI) in Water?
Ensure brevity in your answer.  -3.13. What is the ratio of the Cost (as % of GNI) of Coal in 1980 to that in 1981?
Your answer should be compact. 0.97. What is the ratio of the Cost (as % of GNI) in Minerals in 1980 to that in 1981?
Keep it short and to the point. 1.69. What is the ratio of the Cost (as % of GNI) of Energy in 1980 to that in 1981?
Offer a terse response. 0.87. What is the ratio of the Cost (as % of GNI) in Water in 1980 to that in 1981?
Provide a succinct answer. 0.97. What is the ratio of the Cost (as % of GNI) in Coal in 1980 to that in 1982?
Your answer should be very brief. 0.88. What is the ratio of the Cost (as % of GNI) of Minerals in 1980 to that in 1982?
Provide a short and direct response. 2.14. What is the ratio of the Cost (as % of GNI) of Energy in 1980 to that in 1982?
Keep it short and to the point. 0.92. What is the ratio of the Cost (as % of GNI) of Water in 1980 to that in 1982?
Keep it short and to the point. 0.84. What is the ratio of the Cost (as % of GNI) in Coal in 1980 to that in 1983?
Your answer should be very brief. 0.79. What is the ratio of the Cost (as % of GNI) of Minerals in 1980 to that in 1983?
Give a very brief answer. 1.86. What is the ratio of the Cost (as % of GNI) of Energy in 1980 to that in 1983?
Your answer should be compact. 0.84. What is the ratio of the Cost (as % of GNI) of Water in 1980 to that in 1983?
Offer a very short reply. 0.97. What is the ratio of the Cost (as % of GNI) of Coal in 1980 to that in 1984?
Keep it short and to the point. 0.79. What is the ratio of the Cost (as % of GNI) in Minerals in 1980 to that in 1984?
Keep it short and to the point. 2.19. What is the ratio of the Cost (as % of GNI) in Energy in 1980 to that in 1984?
Your response must be concise. 0.66. What is the ratio of the Cost (as % of GNI) in Water in 1980 to that in 1984?
Keep it short and to the point. 0.88. What is the ratio of the Cost (as % of GNI) of Coal in 1980 to that in 1985?
Give a very brief answer. 0.74. What is the ratio of the Cost (as % of GNI) in Minerals in 1980 to that in 1985?
Offer a terse response. 2.44. What is the ratio of the Cost (as % of GNI) of Energy in 1980 to that in 1985?
Your answer should be compact. 0.74. What is the ratio of the Cost (as % of GNI) in Water in 1980 to that in 1985?
Offer a very short reply. 1.02. What is the ratio of the Cost (as % of GNI) of Coal in 1980 to that in 1986?
Provide a succinct answer. 0.94. What is the ratio of the Cost (as % of GNI) in Minerals in 1980 to that in 1986?
Your answer should be compact. 2.74. What is the ratio of the Cost (as % of GNI) in Water in 1980 to that in 1986?
Make the answer very short. 1.35. What is the ratio of the Cost (as % of GNI) in Coal in 1981 to that in 1982?
Your response must be concise. 0.91. What is the ratio of the Cost (as % of GNI) of Minerals in 1981 to that in 1982?
Give a very brief answer. 1.27. What is the ratio of the Cost (as % of GNI) in Energy in 1981 to that in 1982?
Give a very brief answer. 1.05. What is the ratio of the Cost (as % of GNI) of Water in 1981 to that in 1982?
Provide a short and direct response. 0.87. What is the ratio of the Cost (as % of GNI) of Coal in 1981 to that in 1983?
Give a very brief answer. 0.82. What is the ratio of the Cost (as % of GNI) of Minerals in 1981 to that in 1983?
Offer a terse response. 1.1. What is the ratio of the Cost (as % of GNI) of Energy in 1981 to that in 1983?
Provide a short and direct response. 0.97. What is the ratio of the Cost (as % of GNI) in Water in 1981 to that in 1983?
Provide a succinct answer. 1. What is the ratio of the Cost (as % of GNI) of Coal in 1981 to that in 1984?
Make the answer very short. 0.81. What is the ratio of the Cost (as % of GNI) in Minerals in 1981 to that in 1984?
Offer a terse response. 1.3. What is the ratio of the Cost (as % of GNI) in Energy in 1981 to that in 1984?
Provide a short and direct response. 0.75. What is the ratio of the Cost (as % of GNI) in Water in 1981 to that in 1984?
Provide a short and direct response. 0.91. What is the ratio of the Cost (as % of GNI) of Coal in 1981 to that in 1985?
Your answer should be compact. 0.77. What is the ratio of the Cost (as % of GNI) in Minerals in 1981 to that in 1985?
Your answer should be compact. 1.45. What is the ratio of the Cost (as % of GNI) of Energy in 1981 to that in 1985?
Your response must be concise. 0.85. What is the ratio of the Cost (as % of GNI) in Water in 1981 to that in 1985?
Offer a terse response. 1.05. What is the ratio of the Cost (as % of GNI) of Coal in 1981 to that in 1986?
Your answer should be compact. 0.97. What is the ratio of the Cost (as % of GNI) of Minerals in 1981 to that in 1986?
Offer a terse response. 1.62. What is the ratio of the Cost (as % of GNI) in Energy in 1981 to that in 1986?
Offer a terse response. 2.17. What is the ratio of the Cost (as % of GNI) of Water in 1981 to that in 1986?
Keep it short and to the point. 1.39. What is the ratio of the Cost (as % of GNI) of Coal in 1982 to that in 1983?
Provide a short and direct response. 0.9. What is the ratio of the Cost (as % of GNI) of Minerals in 1982 to that in 1983?
Make the answer very short. 0.87. What is the ratio of the Cost (as % of GNI) of Energy in 1982 to that in 1983?
Your response must be concise. 0.92. What is the ratio of the Cost (as % of GNI) of Water in 1982 to that in 1983?
Keep it short and to the point. 1.15. What is the ratio of the Cost (as % of GNI) in Coal in 1982 to that in 1984?
Provide a succinct answer. 0.9. What is the ratio of the Cost (as % of GNI) of Minerals in 1982 to that in 1984?
Provide a succinct answer. 1.03. What is the ratio of the Cost (as % of GNI) of Energy in 1982 to that in 1984?
Offer a very short reply. 0.72. What is the ratio of the Cost (as % of GNI) in Water in 1982 to that in 1984?
Keep it short and to the point. 1.05. What is the ratio of the Cost (as % of GNI) in Coal in 1982 to that in 1985?
Your answer should be very brief. 0.84. What is the ratio of the Cost (as % of GNI) in Minerals in 1982 to that in 1985?
Provide a succinct answer. 1.14. What is the ratio of the Cost (as % of GNI) of Energy in 1982 to that in 1985?
Offer a very short reply. 0.81. What is the ratio of the Cost (as % of GNI) of Water in 1982 to that in 1985?
Keep it short and to the point. 1.21. What is the ratio of the Cost (as % of GNI) in Coal in 1982 to that in 1986?
Ensure brevity in your answer.  1.07. What is the ratio of the Cost (as % of GNI) in Minerals in 1982 to that in 1986?
Give a very brief answer. 1.28. What is the ratio of the Cost (as % of GNI) of Energy in 1982 to that in 1986?
Provide a succinct answer. 2.07. What is the ratio of the Cost (as % of GNI) in Water in 1982 to that in 1986?
Offer a terse response. 1.6. What is the ratio of the Cost (as % of GNI) in Coal in 1983 to that in 1984?
Provide a short and direct response. 1. What is the ratio of the Cost (as % of GNI) of Minerals in 1983 to that in 1984?
Give a very brief answer. 1.18. What is the ratio of the Cost (as % of GNI) of Energy in 1983 to that in 1984?
Keep it short and to the point. 0.78. What is the ratio of the Cost (as % of GNI) in Water in 1983 to that in 1984?
Give a very brief answer. 0.91. What is the ratio of the Cost (as % of GNI) in Coal in 1983 to that in 1985?
Your answer should be very brief. 0.94. What is the ratio of the Cost (as % of GNI) in Minerals in 1983 to that in 1985?
Provide a succinct answer. 1.32. What is the ratio of the Cost (as % of GNI) in Energy in 1983 to that in 1985?
Offer a terse response. 0.88. What is the ratio of the Cost (as % of GNI) in Water in 1983 to that in 1985?
Your response must be concise. 1.05. What is the ratio of the Cost (as % of GNI) of Coal in 1983 to that in 1986?
Provide a short and direct response. 1.19. What is the ratio of the Cost (as % of GNI) in Minerals in 1983 to that in 1986?
Keep it short and to the point. 1.48. What is the ratio of the Cost (as % of GNI) of Energy in 1983 to that in 1986?
Give a very brief answer. 2.25. What is the ratio of the Cost (as % of GNI) of Water in 1983 to that in 1986?
Offer a terse response. 1.39. What is the ratio of the Cost (as % of GNI) in Coal in 1984 to that in 1985?
Keep it short and to the point. 0.94. What is the ratio of the Cost (as % of GNI) in Minerals in 1984 to that in 1985?
Provide a succinct answer. 1.11. What is the ratio of the Cost (as % of GNI) in Energy in 1984 to that in 1985?
Offer a very short reply. 1.13. What is the ratio of the Cost (as % of GNI) in Water in 1984 to that in 1985?
Give a very brief answer. 1.16. What is the ratio of the Cost (as % of GNI) of Coal in 1984 to that in 1986?
Your answer should be compact. 1.2. What is the ratio of the Cost (as % of GNI) in Minerals in 1984 to that in 1986?
Provide a succinct answer. 1.25. What is the ratio of the Cost (as % of GNI) in Energy in 1984 to that in 1986?
Provide a short and direct response. 2.89. What is the ratio of the Cost (as % of GNI) in Water in 1984 to that in 1986?
Your answer should be compact. 1.53. What is the ratio of the Cost (as % of GNI) in Coal in 1985 to that in 1986?
Provide a succinct answer. 1.27. What is the ratio of the Cost (as % of GNI) of Minerals in 1985 to that in 1986?
Give a very brief answer. 1.12. What is the ratio of the Cost (as % of GNI) of Energy in 1985 to that in 1986?
Your response must be concise. 2.57. What is the ratio of the Cost (as % of GNI) of Water in 1985 to that in 1986?
Keep it short and to the point. 1.32. What is the difference between the highest and the second highest Cost (as % of GNI) of Coal?
Make the answer very short. 0.01. What is the difference between the highest and the second highest Cost (as % of GNI) of Minerals?
Your response must be concise. 0.46. What is the difference between the highest and the second highest Cost (as % of GNI) in Energy?
Give a very brief answer. 0.37. What is the difference between the highest and the second highest Cost (as % of GNI) of Water?
Make the answer very short. 0.31. What is the difference between the highest and the lowest Cost (as % of GNI) in Coal?
Provide a short and direct response. 0.06. What is the difference between the highest and the lowest Cost (as % of GNI) in Minerals?
Give a very brief answer. 0.71. What is the difference between the highest and the lowest Cost (as % of GNI) of Energy?
Offer a very short reply. 2.16. What is the difference between the highest and the lowest Cost (as % of GNI) of Water?
Keep it short and to the point. 2.57. 